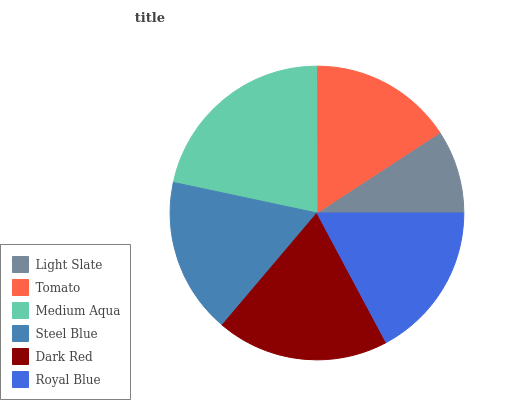Is Light Slate the minimum?
Answer yes or no. Yes. Is Medium Aqua the maximum?
Answer yes or no. Yes. Is Tomato the minimum?
Answer yes or no. No. Is Tomato the maximum?
Answer yes or no. No. Is Tomato greater than Light Slate?
Answer yes or no. Yes. Is Light Slate less than Tomato?
Answer yes or no. Yes. Is Light Slate greater than Tomato?
Answer yes or no. No. Is Tomato less than Light Slate?
Answer yes or no. No. Is Royal Blue the high median?
Answer yes or no. Yes. Is Steel Blue the low median?
Answer yes or no. Yes. Is Tomato the high median?
Answer yes or no. No. Is Dark Red the low median?
Answer yes or no. No. 